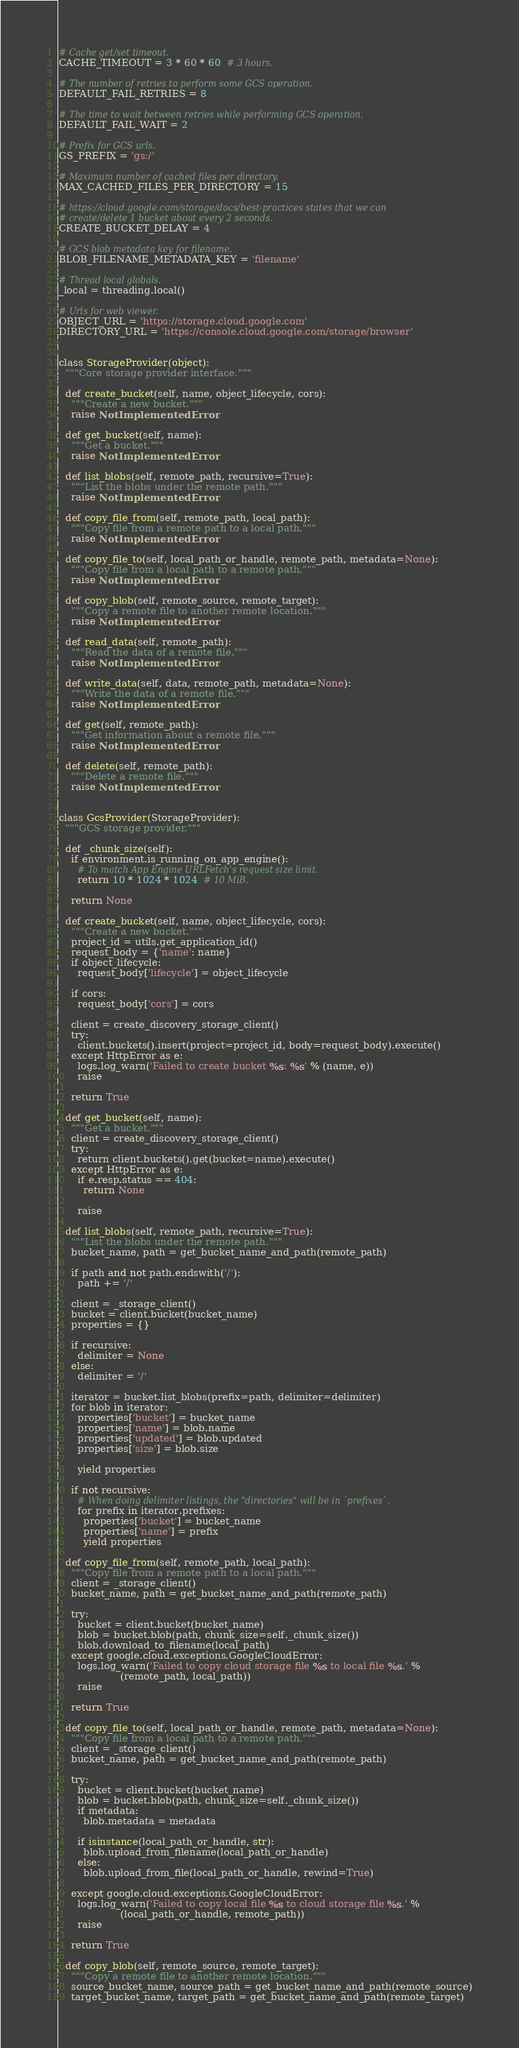<code> <loc_0><loc_0><loc_500><loc_500><_Python_># Cache get/set timeout.
CACHE_TIMEOUT = 3 * 60 * 60  # 3 hours.

# The number of retries to perform some GCS operation.
DEFAULT_FAIL_RETRIES = 8

# The time to wait between retries while performing GCS operation.
DEFAULT_FAIL_WAIT = 2

# Prefix for GCS urls.
GS_PREFIX = 'gs:/'

# Maximum number of cached files per directory.
MAX_CACHED_FILES_PER_DIRECTORY = 15

# https://cloud.google.com/storage/docs/best-practices states that we can
# create/delete 1 bucket about every 2 seconds.
CREATE_BUCKET_DELAY = 4

# GCS blob metadata key for filename.
BLOB_FILENAME_METADATA_KEY = 'filename'

# Thread local globals.
_local = threading.local()

# Urls for web viewer.
OBJECT_URL = 'https://storage.cloud.google.com'
DIRECTORY_URL = 'https://console.cloud.google.com/storage/browser'


class StorageProvider(object):
  """Core storage provider interface."""

  def create_bucket(self, name, object_lifecycle, cors):
    """Create a new bucket."""
    raise NotImplementedError

  def get_bucket(self, name):
    """Get a bucket."""
    raise NotImplementedError

  def list_blobs(self, remote_path, recursive=True):
    """List the blobs under the remote path."""
    raise NotImplementedError

  def copy_file_from(self, remote_path, local_path):
    """Copy file from a remote path to a local path."""
    raise NotImplementedError

  def copy_file_to(self, local_path_or_handle, remote_path, metadata=None):
    """Copy file from a local path to a remote path."""
    raise NotImplementedError

  def copy_blob(self, remote_source, remote_target):
    """Copy a remote file to another remote location."""
    raise NotImplementedError

  def read_data(self, remote_path):
    """Read the data of a remote file."""
    raise NotImplementedError

  def write_data(self, data, remote_path, metadata=None):
    """Write the data of a remote file."""
    raise NotImplementedError

  def get(self, remote_path):
    """Get information about a remote file."""
    raise NotImplementedError

  def delete(self, remote_path):
    """Delete a remote file."""
    raise NotImplementedError


class GcsProvider(StorageProvider):
  """GCS storage provider."""

  def _chunk_size(self):
    if environment.is_running_on_app_engine():
      # To match App Engine URLFetch's request size limit.
      return 10 * 1024 * 1024  # 10 MiB.

    return None

  def create_bucket(self, name, object_lifecycle, cors):
    """Create a new bucket."""
    project_id = utils.get_application_id()
    request_body = {'name': name}
    if object_lifecycle:
      request_body['lifecycle'] = object_lifecycle

    if cors:
      request_body['cors'] = cors

    client = create_discovery_storage_client()
    try:
      client.buckets().insert(project=project_id, body=request_body).execute()
    except HttpError as e:
      logs.log_warn('Failed to create bucket %s: %s' % (name, e))
      raise

    return True

  def get_bucket(self, name):
    """Get a bucket."""
    client = create_discovery_storage_client()
    try:
      return client.buckets().get(bucket=name).execute()
    except HttpError as e:
      if e.resp.status == 404:
        return None

      raise

  def list_blobs(self, remote_path, recursive=True):
    """List the blobs under the remote path."""
    bucket_name, path = get_bucket_name_and_path(remote_path)

    if path and not path.endswith('/'):
      path += '/'

    client = _storage_client()
    bucket = client.bucket(bucket_name)
    properties = {}

    if recursive:
      delimiter = None
    else:
      delimiter = '/'

    iterator = bucket.list_blobs(prefix=path, delimiter=delimiter)
    for blob in iterator:
      properties['bucket'] = bucket_name
      properties['name'] = blob.name
      properties['updated'] = blob.updated
      properties['size'] = blob.size

      yield properties

    if not recursive:
      # When doing delimiter listings, the "directories" will be in `prefixes`.
      for prefix in iterator.prefixes:
        properties['bucket'] = bucket_name
        properties['name'] = prefix
        yield properties

  def copy_file_from(self, remote_path, local_path):
    """Copy file from a remote path to a local path."""
    client = _storage_client()
    bucket_name, path = get_bucket_name_and_path(remote_path)

    try:
      bucket = client.bucket(bucket_name)
      blob = bucket.blob(path, chunk_size=self._chunk_size())
      blob.download_to_filename(local_path)
    except google.cloud.exceptions.GoogleCloudError:
      logs.log_warn('Failed to copy cloud storage file %s to local file %s.' %
                    (remote_path, local_path))
      raise

    return True

  def copy_file_to(self, local_path_or_handle, remote_path, metadata=None):
    """Copy file from a local path to a remote path."""
    client = _storage_client()
    bucket_name, path = get_bucket_name_and_path(remote_path)

    try:
      bucket = client.bucket(bucket_name)
      blob = bucket.blob(path, chunk_size=self._chunk_size())
      if metadata:
        blob.metadata = metadata

      if isinstance(local_path_or_handle, str):
        blob.upload_from_filename(local_path_or_handle)
      else:
        blob.upload_from_file(local_path_or_handle, rewind=True)

    except google.cloud.exceptions.GoogleCloudError:
      logs.log_warn('Failed to copy local file %s to cloud storage file %s.' %
                    (local_path_or_handle, remote_path))
      raise

    return True

  def copy_blob(self, remote_source, remote_target):
    """Copy a remote file to another remote location."""
    source_bucket_name, source_path = get_bucket_name_and_path(remote_source)
    target_bucket_name, target_path = get_bucket_name_and_path(remote_target)
</code> 